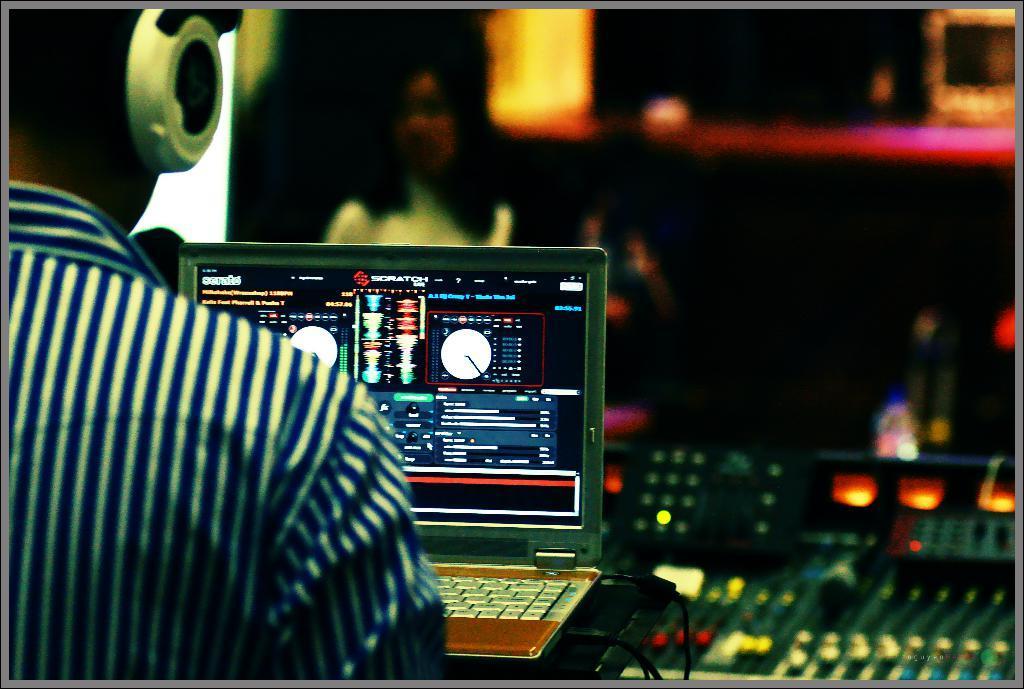In one or two sentences, can you explain what this image depicts? The man on the left side is wearing the headset. In front of him, we see a laptop is placed on the black table. Behind that, we see the music recorders. In the background, we see a water bottle, pink color object and a woman is standing. This picture is blurred in the background. 